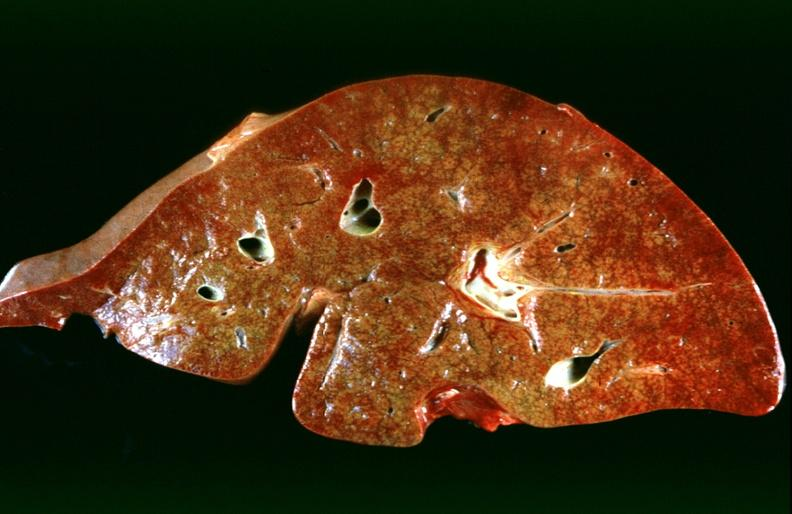does hematoma show hepatic congestion due to congestive heart failure?
Answer the question using a single word or phrase. No 